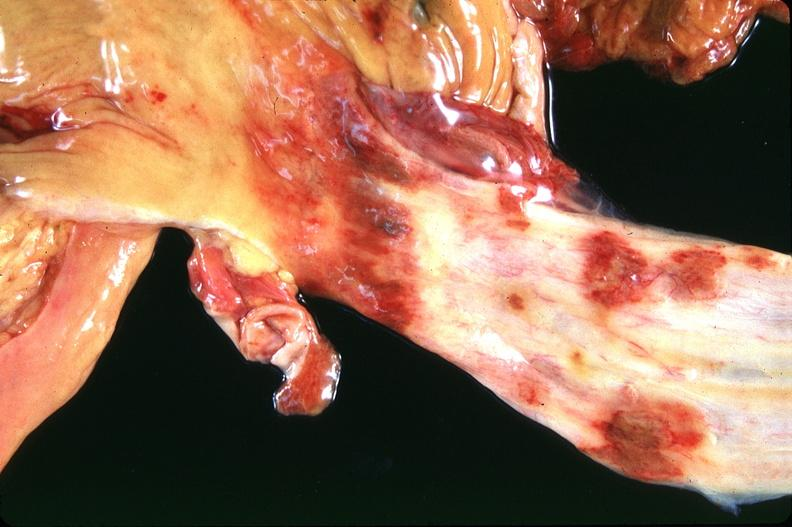s medial aspect present?
Answer the question using a single word or phrase. No 